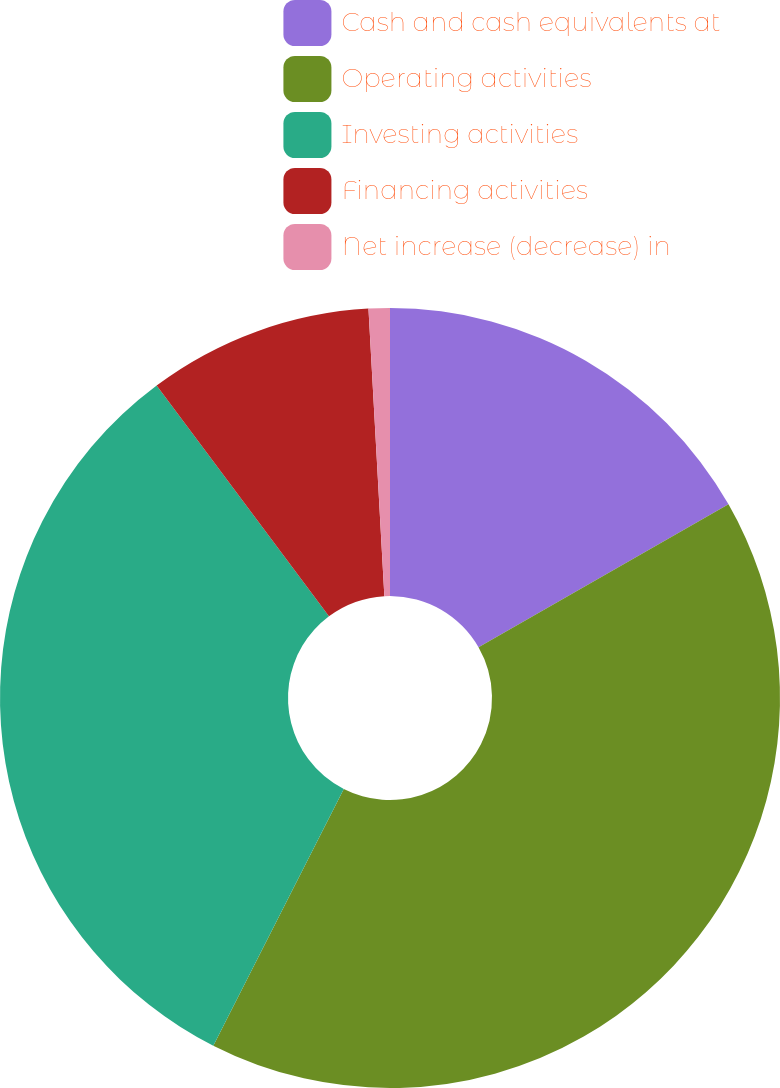Convert chart. <chart><loc_0><loc_0><loc_500><loc_500><pie_chart><fcel>Cash and cash equivalents at<fcel>Operating activities<fcel>Investing activities<fcel>Financing activities<fcel>Net increase (decrease) in<nl><fcel>16.73%<fcel>40.76%<fcel>32.31%<fcel>9.33%<fcel>0.88%<nl></chart> 